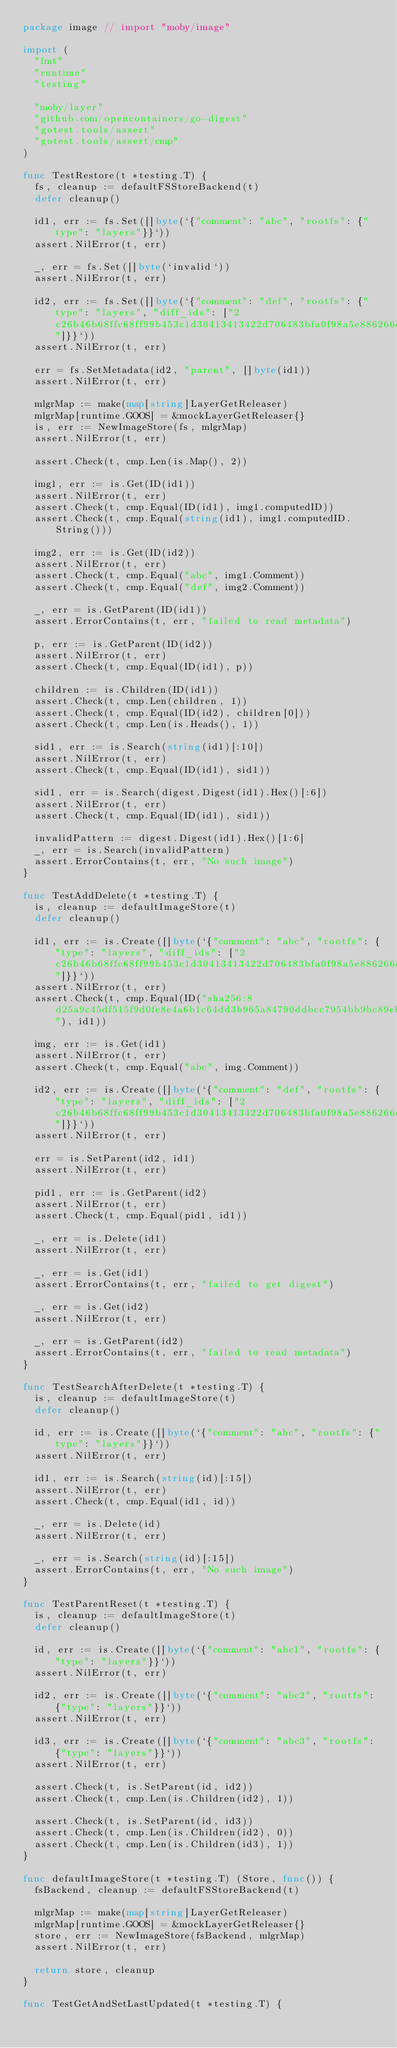Convert code to text. <code><loc_0><loc_0><loc_500><loc_500><_Go_>package image // import "moby/image"

import (
	"fmt"
	"runtime"
	"testing"

	"moby/layer"
	"github.com/opencontainers/go-digest"
	"gotest.tools/assert"
	"gotest.tools/assert/cmp"
)

func TestRestore(t *testing.T) {
	fs, cleanup := defaultFSStoreBackend(t)
	defer cleanup()

	id1, err := fs.Set([]byte(`{"comment": "abc", "rootfs": {"type": "layers"}}`))
	assert.NilError(t, err)

	_, err = fs.Set([]byte(`invalid`))
	assert.NilError(t, err)

	id2, err := fs.Set([]byte(`{"comment": "def", "rootfs": {"type": "layers", "diff_ids": ["2c26b46b68ffc68ff99b453c1d30413413422d706483bfa0f98a5e886266e7ae"]}}`))
	assert.NilError(t, err)

	err = fs.SetMetadata(id2, "parent", []byte(id1))
	assert.NilError(t, err)

	mlgrMap := make(map[string]LayerGetReleaser)
	mlgrMap[runtime.GOOS] = &mockLayerGetReleaser{}
	is, err := NewImageStore(fs, mlgrMap)
	assert.NilError(t, err)

	assert.Check(t, cmp.Len(is.Map(), 2))

	img1, err := is.Get(ID(id1))
	assert.NilError(t, err)
	assert.Check(t, cmp.Equal(ID(id1), img1.computedID))
	assert.Check(t, cmp.Equal(string(id1), img1.computedID.String()))

	img2, err := is.Get(ID(id2))
	assert.NilError(t, err)
	assert.Check(t, cmp.Equal("abc", img1.Comment))
	assert.Check(t, cmp.Equal("def", img2.Comment))

	_, err = is.GetParent(ID(id1))
	assert.ErrorContains(t, err, "failed to read metadata")

	p, err := is.GetParent(ID(id2))
	assert.NilError(t, err)
	assert.Check(t, cmp.Equal(ID(id1), p))

	children := is.Children(ID(id1))
	assert.Check(t, cmp.Len(children, 1))
	assert.Check(t, cmp.Equal(ID(id2), children[0]))
	assert.Check(t, cmp.Len(is.Heads(), 1))

	sid1, err := is.Search(string(id1)[:10])
	assert.NilError(t, err)
	assert.Check(t, cmp.Equal(ID(id1), sid1))

	sid1, err = is.Search(digest.Digest(id1).Hex()[:6])
	assert.NilError(t, err)
	assert.Check(t, cmp.Equal(ID(id1), sid1))

	invalidPattern := digest.Digest(id1).Hex()[1:6]
	_, err = is.Search(invalidPattern)
	assert.ErrorContains(t, err, "No such image")
}

func TestAddDelete(t *testing.T) {
	is, cleanup := defaultImageStore(t)
	defer cleanup()

	id1, err := is.Create([]byte(`{"comment": "abc", "rootfs": {"type": "layers", "diff_ids": ["2c26b46b68ffc68ff99b453c1d30413413422d706483bfa0f98a5e886266e7ae"]}}`))
	assert.NilError(t, err)
	assert.Check(t, cmp.Equal(ID("sha256:8d25a9c45df515f9d0fe8e4a6b1c64dd3b965a84790ddbcc7954bb9bc89eb993"), id1))

	img, err := is.Get(id1)
	assert.NilError(t, err)
	assert.Check(t, cmp.Equal("abc", img.Comment))

	id2, err := is.Create([]byte(`{"comment": "def", "rootfs": {"type": "layers", "diff_ids": ["2c26b46b68ffc68ff99b453c1d30413413422d706483bfa0f98a5e886266e7ae"]}}`))
	assert.NilError(t, err)

	err = is.SetParent(id2, id1)
	assert.NilError(t, err)

	pid1, err := is.GetParent(id2)
	assert.NilError(t, err)
	assert.Check(t, cmp.Equal(pid1, id1))

	_, err = is.Delete(id1)
	assert.NilError(t, err)

	_, err = is.Get(id1)
	assert.ErrorContains(t, err, "failed to get digest")

	_, err = is.Get(id2)
	assert.NilError(t, err)

	_, err = is.GetParent(id2)
	assert.ErrorContains(t, err, "failed to read metadata")
}

func TestSearchAfterDelete(t *testing.T) {
	is, cleanup := defaultImageStore(t)
	defer cleanup()

	id, err := is.Create([]byte(`{"comment": "abc", "rootfs": {"type": "layers"}}`))
	assert.NilError(t, err)

	id1, err := is.Search(string(id)[:15])
	assert.NilError(t, err)
	assert.Check(t, cmp.Equal(id1, id))

	_, err = is.Delete(id)
	assert.NilError(t, err)

	_, err = is.Search(string(id)[:15])
	assert.ErrorContains(t, err, "No such image")
}

func TestParentReset(t *testing.T) {
	is, cleanup := defaultImageStore(t)
	defer cleanup()

	id, err := is.Create([]byte(`{"comment": "abc1", "rootfs": {"type": "layers"}}`))
	assert.NilError(t, err)

	id2, err := is.Create([]byte(`{"comment": "abc2", "rootfs": {"type": "layers"}}`))
	assert.NilError(t, err)

	id3, err := is.Create([]byte(`{"comment": "abc3", "rootfs": {"type": "layers"}}`))
	assert.NilError(t, err)

	assert.Check(t, is.SetParent(id, id2))
	assert.Check(t, cmp.Len(is.Children(id2), 1))

	assert.Check(t, is.SetParent(id, id3))
	assert.Check(t, cmp.Len(is.Children(id2), 0))
	assert.Check(t, cmp.Len(is.Children(id3), 1))
}

func defaultImageStore(t *testing.T) (Store, func()) {
	fsBackend, cleanup := defaultFSStoreBackend(t)

	mlgrMap := make(map[string]LayerGetReleaser)
	mlgrMap[runtime.GOOS] = &mockLayerGetReleaser{}
	store, err := NewImageStore(fsBackend, mlgrMap)
	assert.NilError(t, err)

	return store, cleanup
}

func TestGetAndSetLastUpdated(t *testing.T) {</code> 